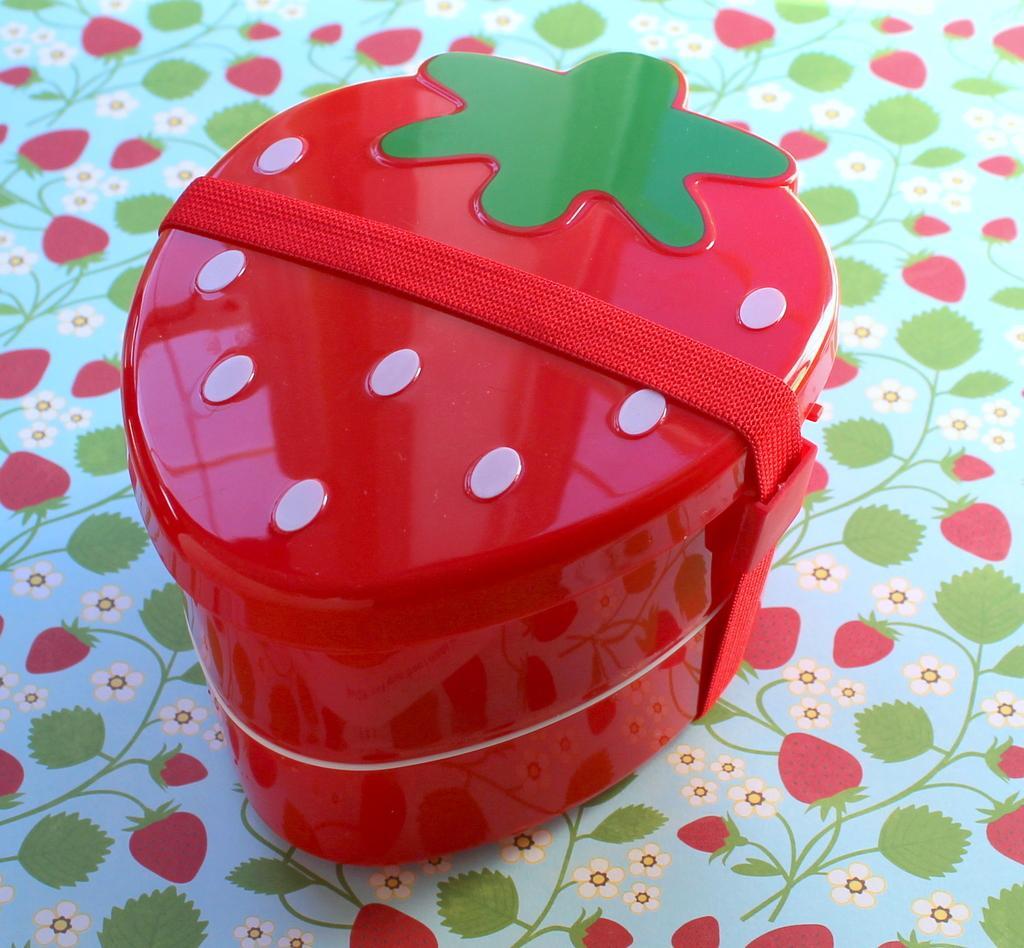Please provide a concise description of this image. In the image we can see there is a strawberry shaped tiffin box kept on the table. 